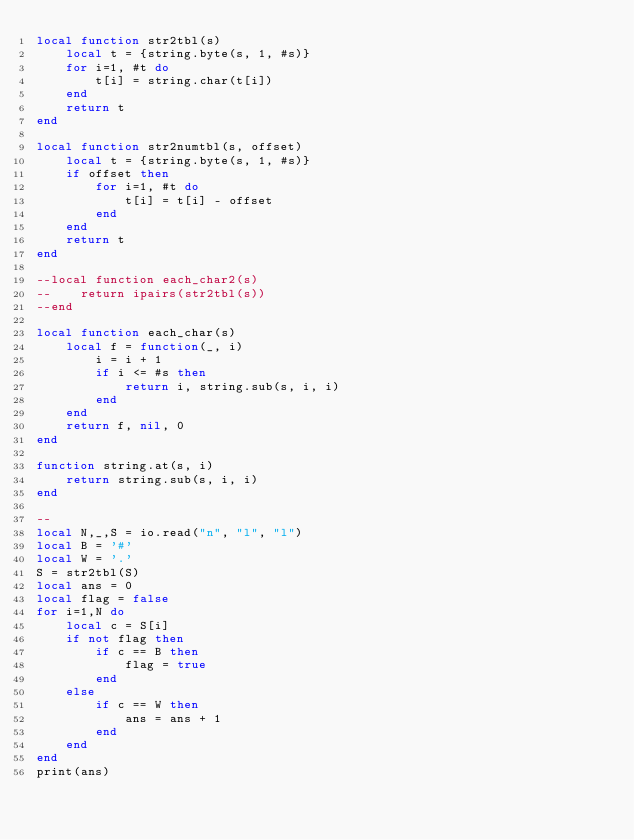<code> <loc_0><loc_0><loc_500><loc_500><_Lua_>local function str2tbl(s)
    local t = {string.byte(s, 1, #s)}
    for i=1, #t do
        t[i] = string.char(t[i])
    end
    return t
end

local function str2numtbl(s, offset)
    local t = {string.byte(s, 1, #s)}
    if offset then
        for i=1, #t do
            t[i] = t[i] - offset
        end
    end
    return t
end

--local function each_char2(s)
--    return ipairs(str2tbl(s))
--end

local function each_char(s)
    local f = function(_, i)
        i = i + 1
        if i <= #s then
            return i, string.sub(s, i, i)
        end
    end
    return f, nil, 0
end

function string.at(s, i)
    return string.sub(s, i, i)
end

--
local N,_,S = io.read("n", "l", "l")
local B = '#'
local W = '.'
S = str2tbl(S)
local ans = 0
local flag = false
for i=1,N do
    local c = S[i]
    if not flag then
        if c == B then
            flag = true
        end
    else
        if c == W then
            ans = ans + 1
        end
    end
end
print(ans)</code> 